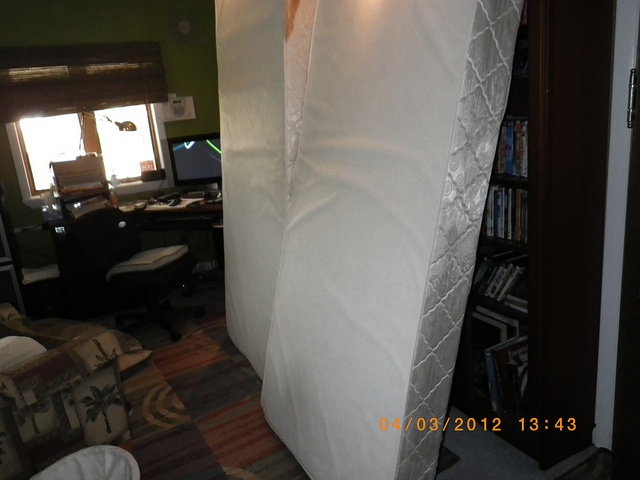Describe the objects in this image and their specific colors. I can see bed in black, darkgray, gray, and tan tones, bed in black, gray, and darkgray tones, book in black and gray tones, chair in black and gray tones, and tv in black, gray, and blue tones in this image. 